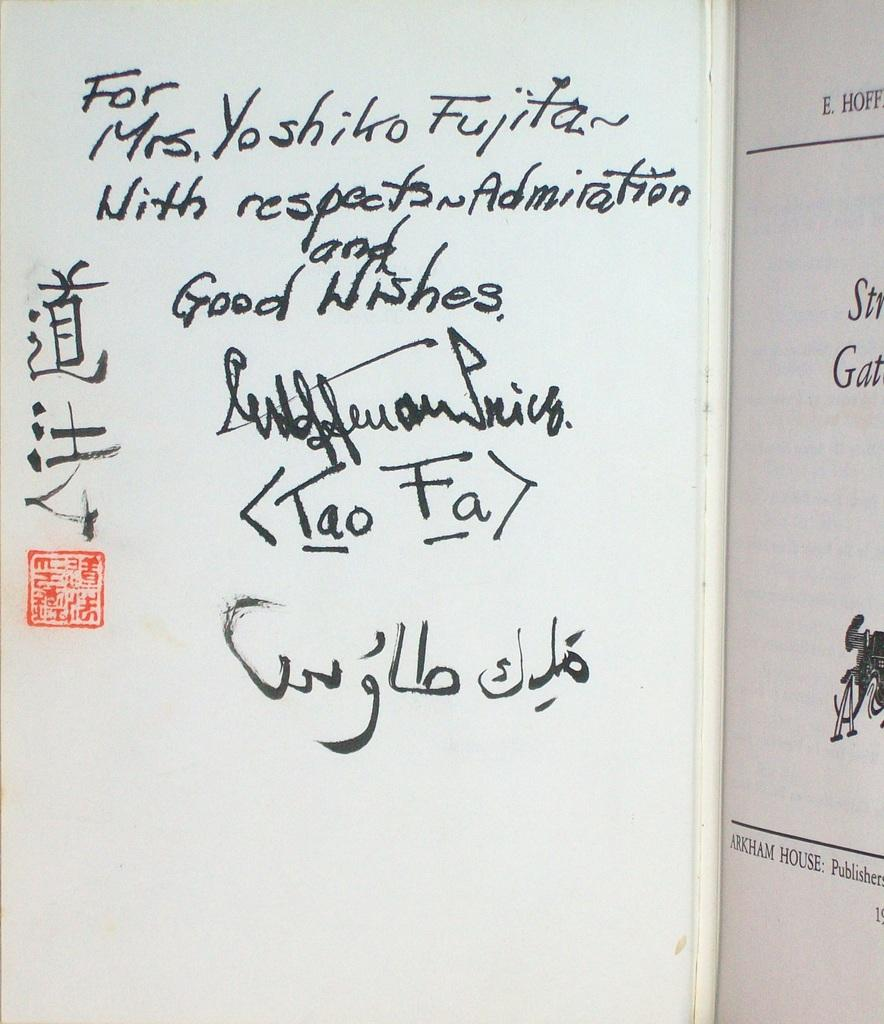<image>
Provide a brief description of the given image. A whiteboard has the words "For Mrs. Yoshiko Fujita" written on it 